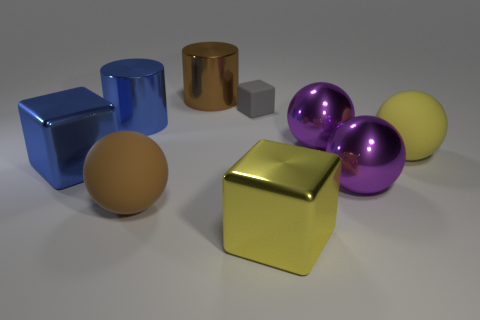Subtract all cyan cylinders. How many purple balls are left? 2 Subtract all large yellow matte balls. How many balls are left? 3 Subtract all brown spheres. How many spheres are left? 3 Subtract 1 spheres. How many spheres are left? 3 Subtract all cyan blocks. Subtract all cyan spheres. How many blocks are left? 3 Subtract all cylinders. How many objects are left? 7 Subtract 0 gray balls. How many objects are left? 9 Subtract all big yellow cubes. Subtract all big brown rubber objects. How many objects are left? 7 Add 5 big metal cubes. How many big metal cubes are left? 7 Add 1 big blue shiny cylinders. How many big blue shiny cylinders exist? 2 